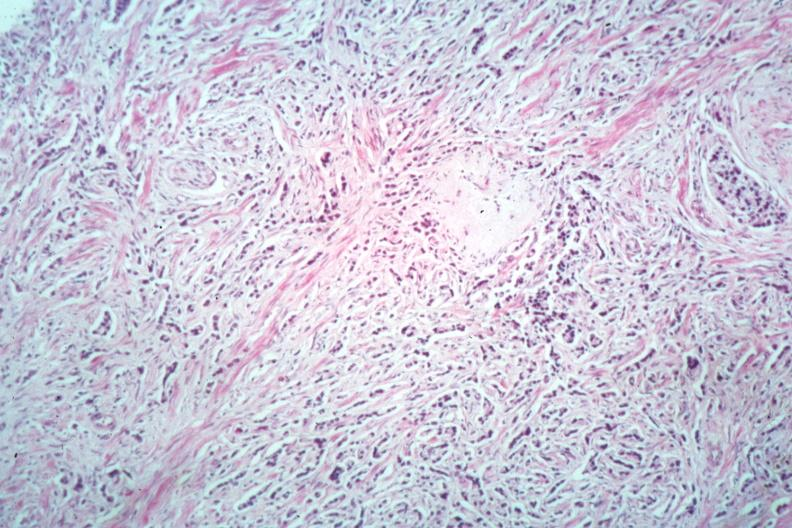s prostate present?
Answer the question using a single word or phrase. Yes 